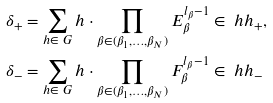<formula> <loc_0><loc_0><loc_500><loc_500>\delta _ { + } & = \sum _ { h \in \ G } h \cdot \prod _ { \beta \in ( \beta _ { 1 } , \dots , \beta _ { N } ) } E _ { \beta } ^ { l _ { \beta } - 1 } \in \ h h _ { + } , \\ \delta _ { - } & = \sum _ { h \in \ G } h \cdot \prod _ { \beta \in ( \beta _ { 1 } , \dots , \beta _ { N } ) } F _ { \beta } ^ { l _ { \beta } - 1 } \in \ h h _ { - }</formula> 